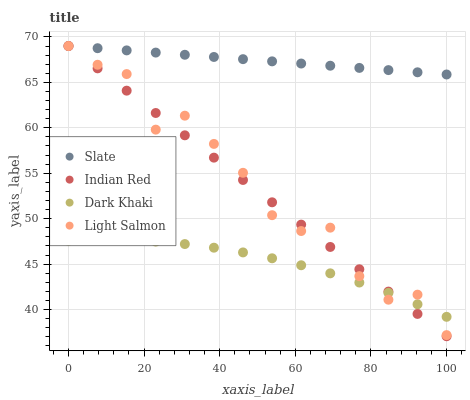Does Dark Khaki have the minimum area under the curve?
Answer yes or no. Yes. Does Slate have the maximum area under the curve?
Answer yes or no. Yes. Does Light Salmon have the minimum area under the curve?
Answer yes or no. No. Does Light Salmon have the maximum area under the curve?
Answer yes or no. No. Is Indian Red the smoothest?
Answer yes or no. Yes. Is Light Salmon the roughest?
Answer yes or no. Yes. Is Slate the smoothest?
Answer yes or no. No. Is Slate the roughest?
Answer yes or no. No. Does Indian Red have the lowest value?
Answer yes or no. Yes. Does Light Salmon have the lowest value?
Answer yes or no. No. Does Indian Red have the highest value?
Answer yes or no. Yes. Is Dark Khaki less than Slate?
Answer yes or no. Yes. Is Slate greater than Dark Khaki?
Answer yes or no. Yes. Does Light Salmon intersect Dark Khaki?
Answer yes or no. Yes. Is Light Salmon less than Dark Khaki?
Answer yes or no. No. Is Light Salmon greater than Dark Khaki?
Answer yes or no. No. Does Dark Khaki intersect Slate?
Answer yes or no. No. 